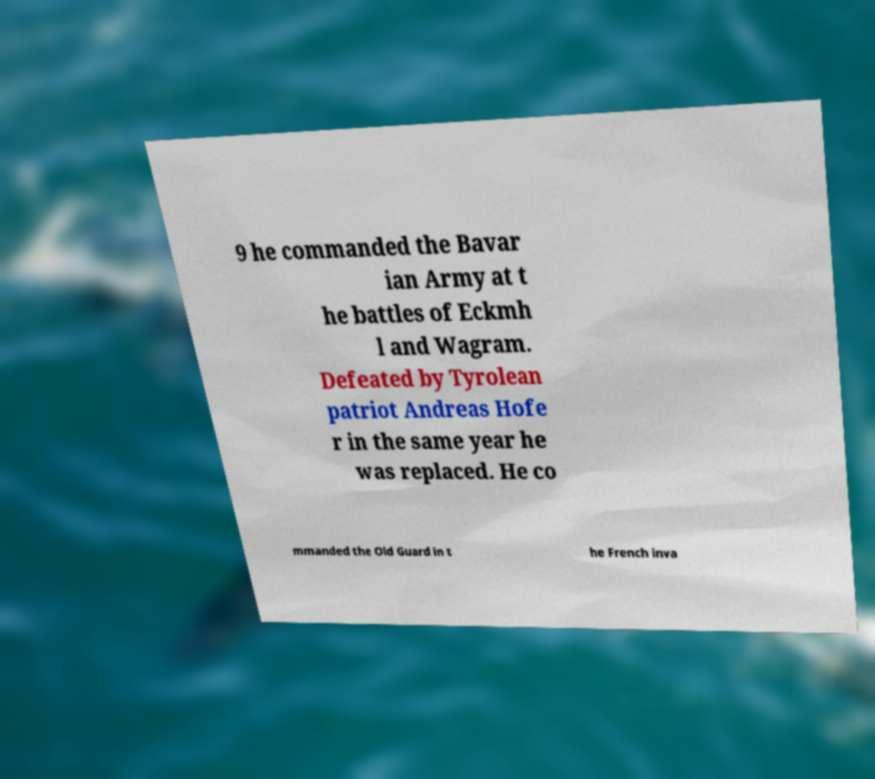Could you extract and type out the text from this image? 9 he commanded the Bavar ian Army at t he battles of Eckmh l and Wagram. Defeated by Tyrolean patriot Andreas Hofe r in the same year he was replaced. He co mmanded the Old Guard in t he French inva 